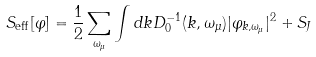<formula> <loc_0><loc_0><loc_500><loc_500>S _ { \text {eff} } [ \varphi ] = \frac { 1 } { 2 } \sum _ { \omega _ { \mu } } \int d { k } D ^ { - 1 } _ { 0 } ( k , \omega _ { \mu } ) | \varphi _ { k , \omega _ { \mu } } | ^ { 2 } + S _ { J }</formula> 